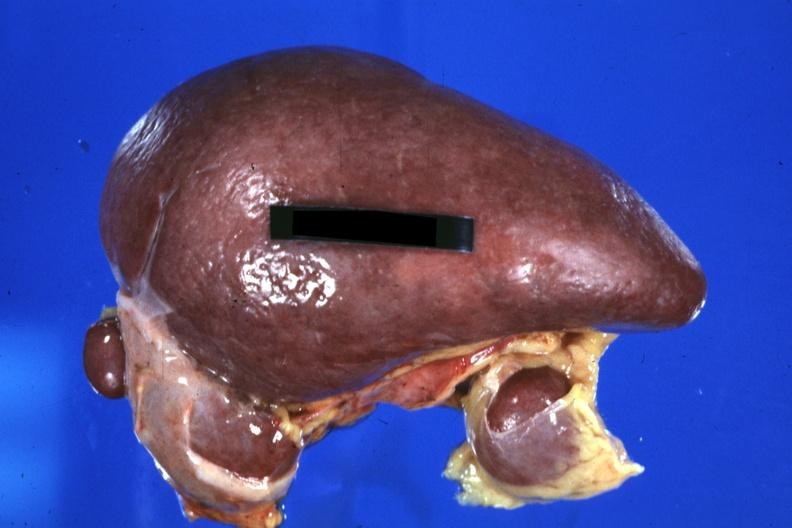does normal show spleen with three accessories 32yobf left isomerism and complex congenital heart disease?
Answer the question using a single word or phrase. No 